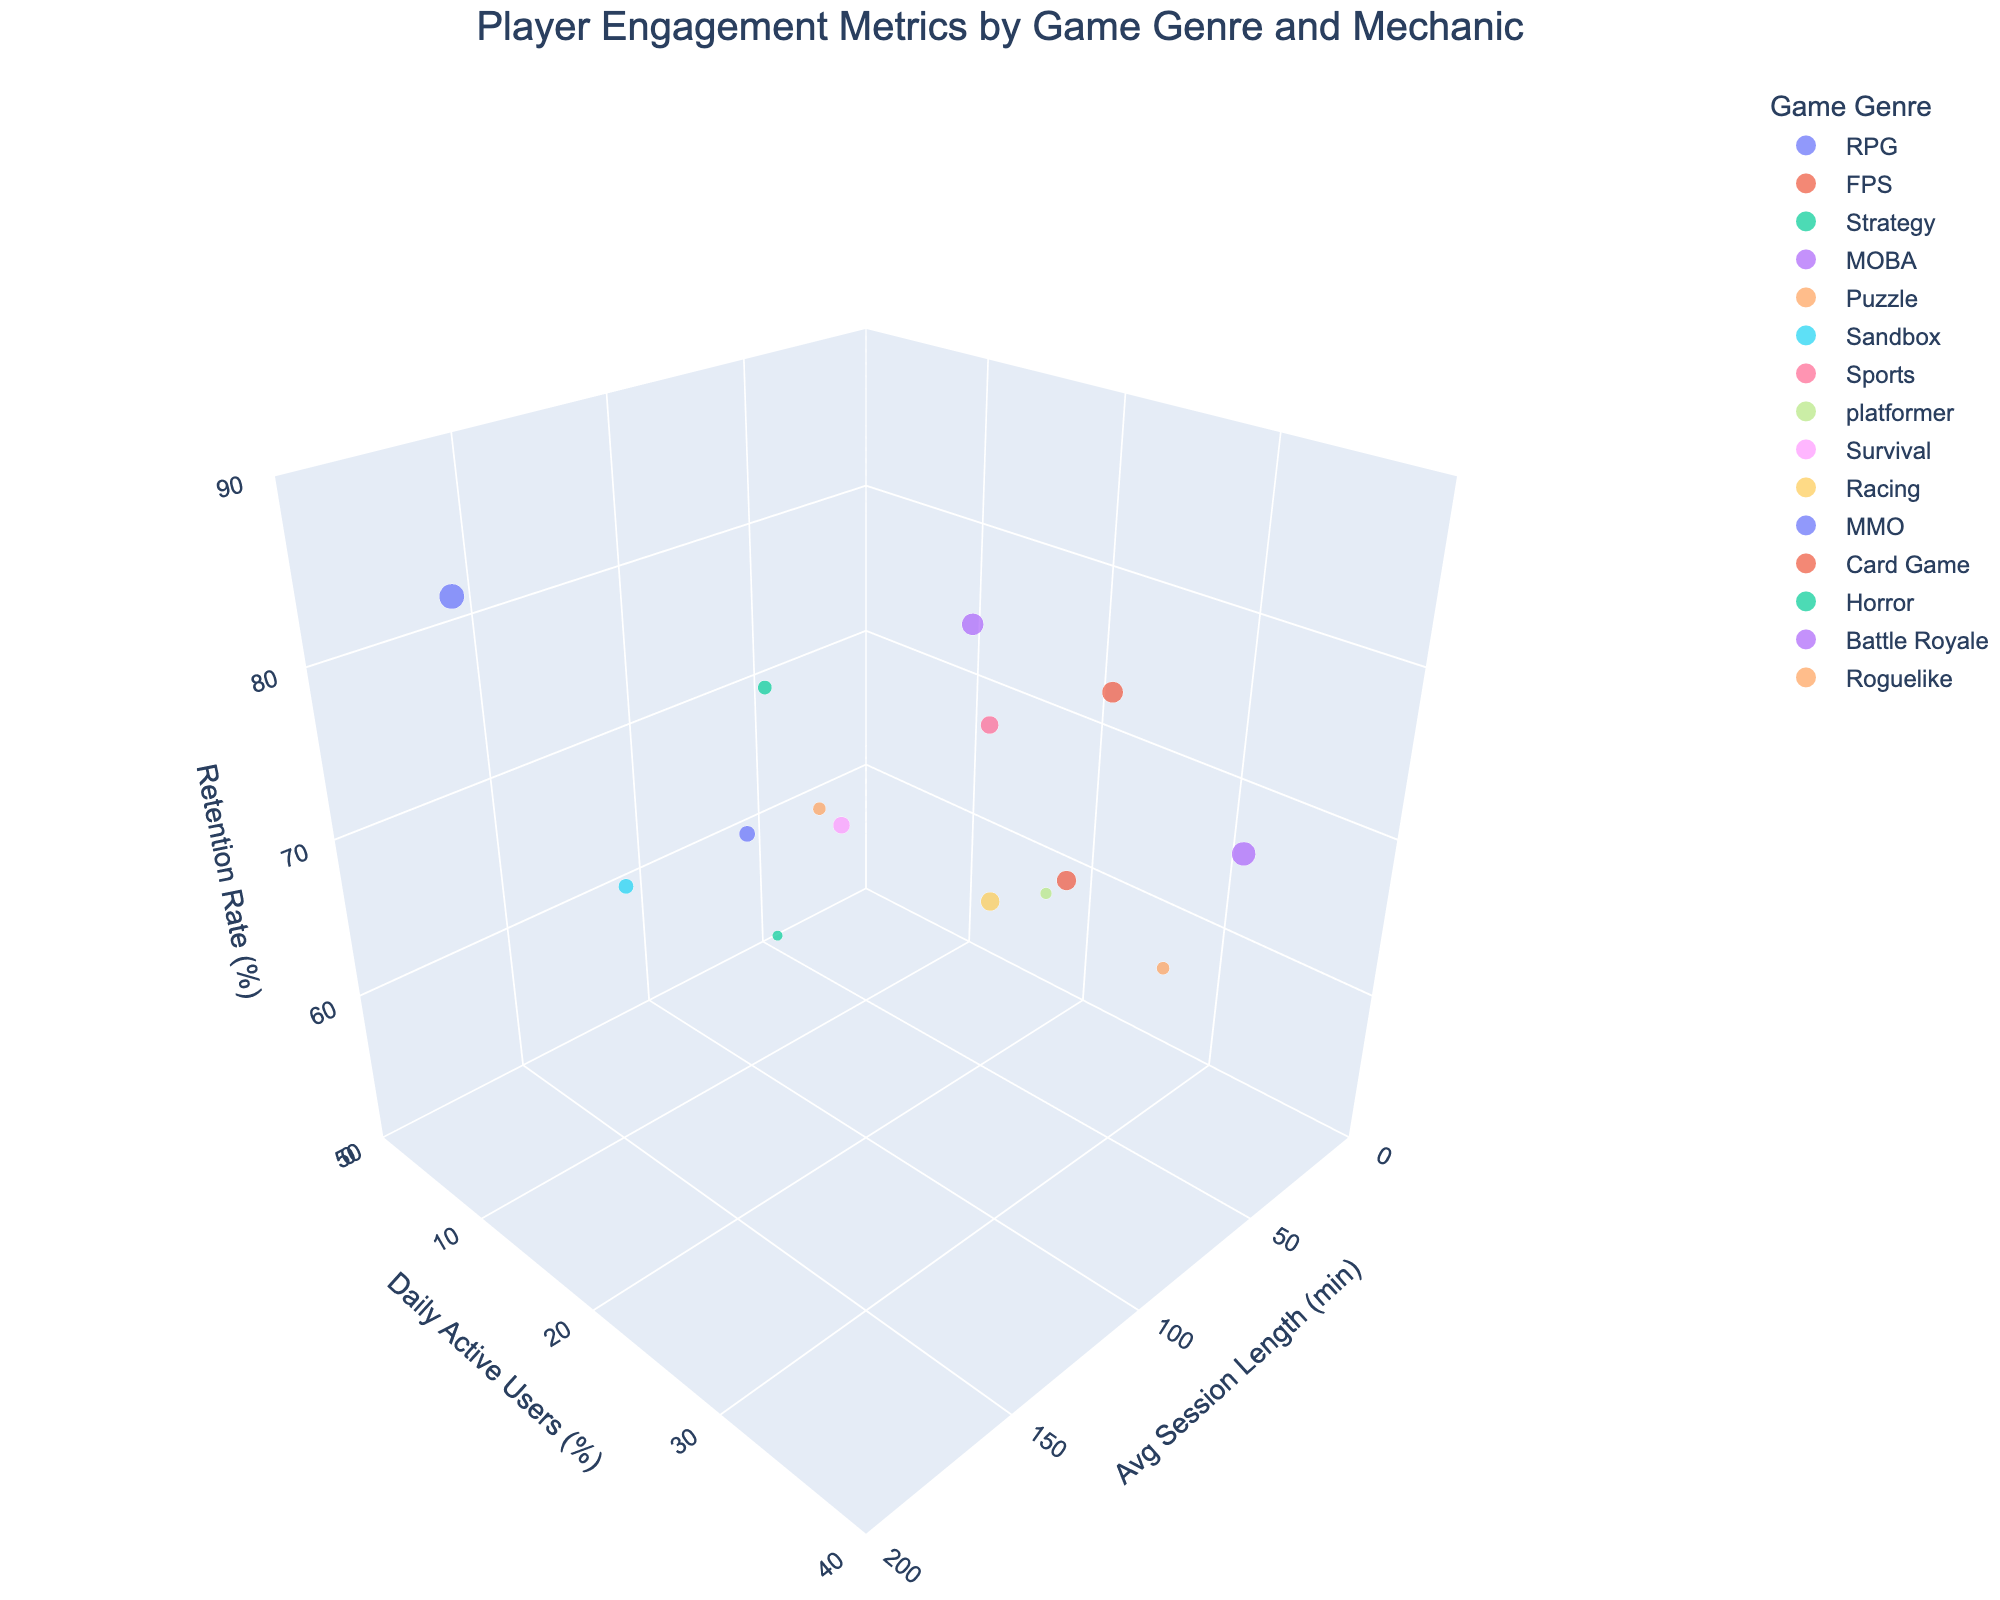What's the title of the chart? The title of the chart is displayed at the top center. It reads, "Player Engagement Metrics by Game Genre and Mechanic."
Answer: Player Engagement Metrics by Game Genre and Mechanic Which game genre has the highest retention rate? By looking at the z-axis representing the retention rate, the MMO genre stands out with the highest retention rate of 85%.
Answer: MMO How many game genres are displayed in the plot? Each bubble in the chart is colored differently by game genre, and the legend lists the distinct genres. Counting these, there are 15 game genres.
Answer: 15 What's the average daily active users percentage between RPG and FPS genres? For RPG, the daily active users is 15%. For FPS, it is 25%. The average is calculated as (15 + 25) / 2 = 20%.
Answer: 20% Which game mechanic features the longest average session length? By examining the x-axis for average session length, the MMO genre with the mechanic "Social Interaction" displays the longest average session length of 180 minutes.
Answer: Social Interaction Compare the monetization rates of Puzzle and Racing genres. The size of the bubble indicates the monetization rate. Puzzle genre has a rate of 5%, while the Racing genre has a rate of 11%. Hence, Racing has a higher monetization rate.
Answer: Racing What is the characteristic of the bubble representing the highest monetization rate? The largest bubble represents the Battle Royale genre with the "Last Man Standing" mechanic, having a monetization rate of 18%, as indicated by its size.
Answer: Battle Royale, Last Man Standing For the game genre with the shortest average session length, what is its daily active users percentage? The genre with the shortest average session length is Racing (25 min). This genre has a daily active users percentage of 16%.
Answer: 16% Calculate the difference in retention rate between Strategy and Horror genres. The retention rate for Strategy is 75%, while for Horror, it is 55%. The difference is 75% - 55% = 20%.
Answer: 20% Which game genre has the maximum daily active users percentage and how large is the bubble representing it? The highest daily active users percentage is 35%, represented by the Battle Royale genre. The bubble size correlates with a monetization rate of 18%.
Answer: Battle Royale, 18% 